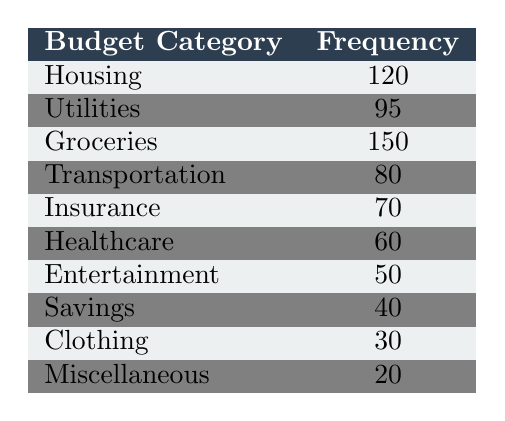What is the most frequently chosen budget category? The highest frequency in the table corresponds to the category "Groceries," which has a frequency of 150.
Answer: Groceries How many tenants reported spending on Housing? The frequency for the Housing category in the table is 120.
Answer: 120 What is the frequency difference between Utilities and Insurance? The frequency for Utilities is 95 and for Insurance is 70. The difference is 95 - 70 = 25.
Answer: 25 Is Transportation one of the top three budget categories? The top three categories by frequency are Groceries, Housing, and Utilities. Transportation is not in the top three as it has a frequency of 80.
Answer: No What is the total frequency of the categories that have a frequency greater than 60? The categories with a frequency greater than 60 are Housing (120), Utilities (95), Groceries (150), and Transportation (80). Adding these gives: 120 + 95 + 150 + 80 = 445.
Answer: 445 Calculate the average frequency of all budget categories. To find the average frequency, we need to sum all frequencies and then divide by the number of categories. The total frequency is 120 + 95 + 150 + 80 + 70 + 60 + 50 + 40 + 30 + 20 = 795. There are 10 categories, so the average is 795 / 10 = 79.5.
Answer: 79.5 How many budget categories have a frequency less than 50? The categories with a frequency less than 50 are Entertainment (50), Savings (40), Clothing (30), and Miscellaneous (20). Therefore, there are three categories below 50: Clothing and Miscellaneous (50 counts as not less).
Answer: 2 What is the combined frequency of Healthcare and Entertainment? The frequency for Healthcare is 60 and for Entertainment is 50. The total combined frequency is 60 + 50 = 110.
Answer: 110 Is the frequency of Clothing more than the frequency of Savings? The frequency for Clothing is 30 and for Savings is 40. Since 30 is less than 40, Clothing does not have a higher frequency.
Answer: No 